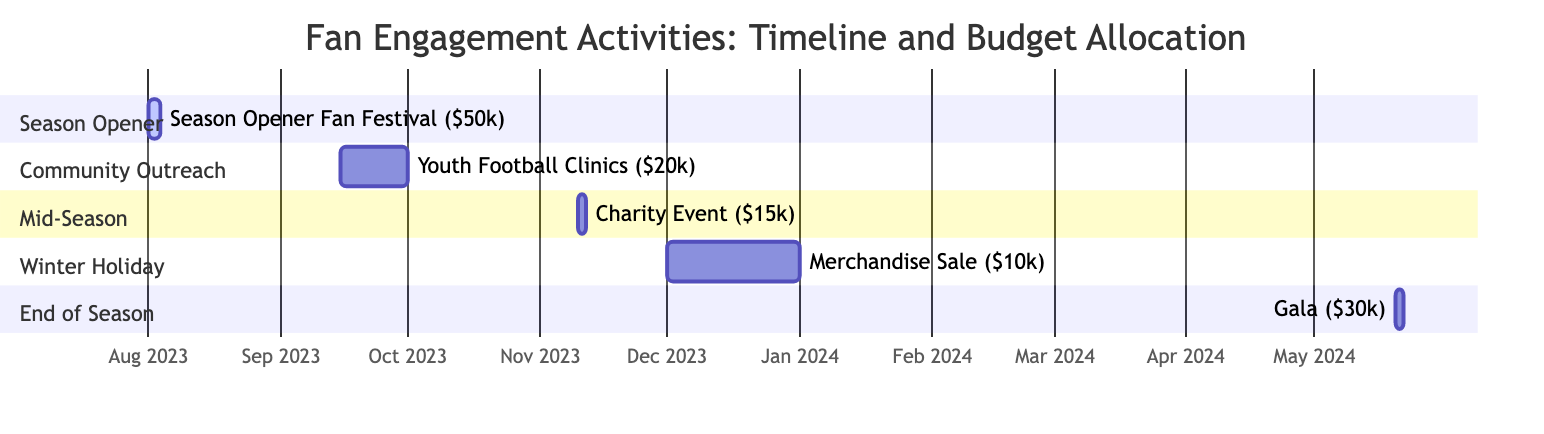What is the budget for the Season Opener Fan Festival? The diagram states that the budget for the Season Opener Fan Festival is clearly labeled as $50k.
Answer: $50k How many activities are associated with the Community Outreach event? The Community Outreach - Youth Football Clinics have four activities listed under it: Free Coaching Sessions, Autograph Sessions with Players, Health and Nutrition Workshops, and Distribution of Free Football Kits. This shows that there are four activities in total.
Answer: 4 What two activities are part of the Mid-Season Charity Event? The Mid-Season Charity Event has the following activities: Charity Auction, Friendly Match with Local Teams, Raffle Draw, and Fundraising Dinner. Among these, the first two activities are Charity Auction and Friendly Match with Local Teams.
Answer: Charity Auction, Friendly Match with Local Teams Which event has the lowest budget? By comparing the budgets allocated in the diagram, the Winter Holiday Merchandise Sale has the lowest budget of $10k.
Answer: $10k What is the duration of the Winter Holiday Merchandise Sale? The Winter Holiday Merchandise Sale starts on December 1, 2023, and ends on December 31, 2023. This gives it a total duration of 31 days.
Answer: 31 days How does the total budget for all events compare to the budget of the End of Season Gala? The total budget for all events is $50k + $20k + $15k + $10k + $30k = $125k. The budget for the End of Season Gala is $30k. Therefore, the total budget exceeds the End of Season Gala budget by $95k.
Answer: $95k When will the End of Season Gala occur? The End of Season Gala is scheduled to occur on May 20 and 21, 2024, as indicated in the timeline of the Gantt chart.
Answer: May 20-21, 2024 What event occurs directly after the end of the Community Outreach - Youth Football Clinics? The Gantt chart shows that the Mid-Season Charity Event starts immediately after the Community Outreach - Youth Football Clinics, indicating that it follows directly in the timeline.
Answer: Mid-Season Charity Event What is the first event listed in the Gantt chart? The first event in the Gantt chart is the Season Opener Fan Festival, which is marked as the initial entry in the diagram's timeline.
Answer: Season Opener Fan Festival 